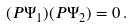Convert formula to latex. <formula><loc_0><loc_0><loc_500><loc_500>( P \Psi _ { 1 } ) ( P \Psi _ { 2 } ) = 0 \, .</formula> 